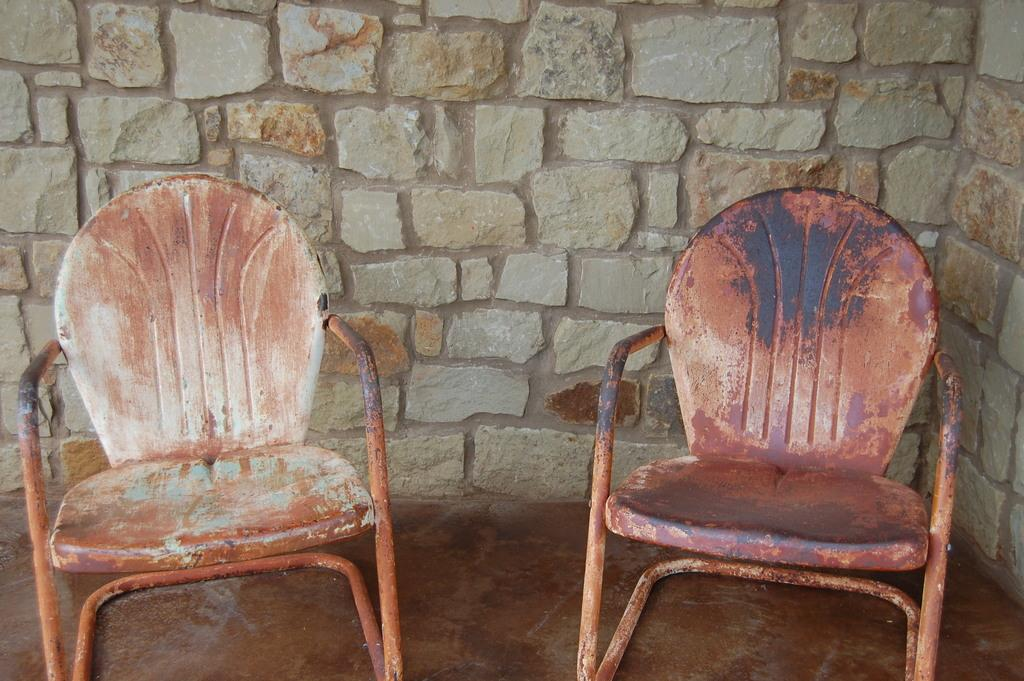How many chairs are visible in the image? There are two chairs in the image. Where are the chairs located? The chairs are on the ground. What can be seen in the background of the image? There is a wall in the background of the image. How many ears can be seen on the head of the person in the image? There is no person present in the image, so it is not possible to see any ears or a head. 